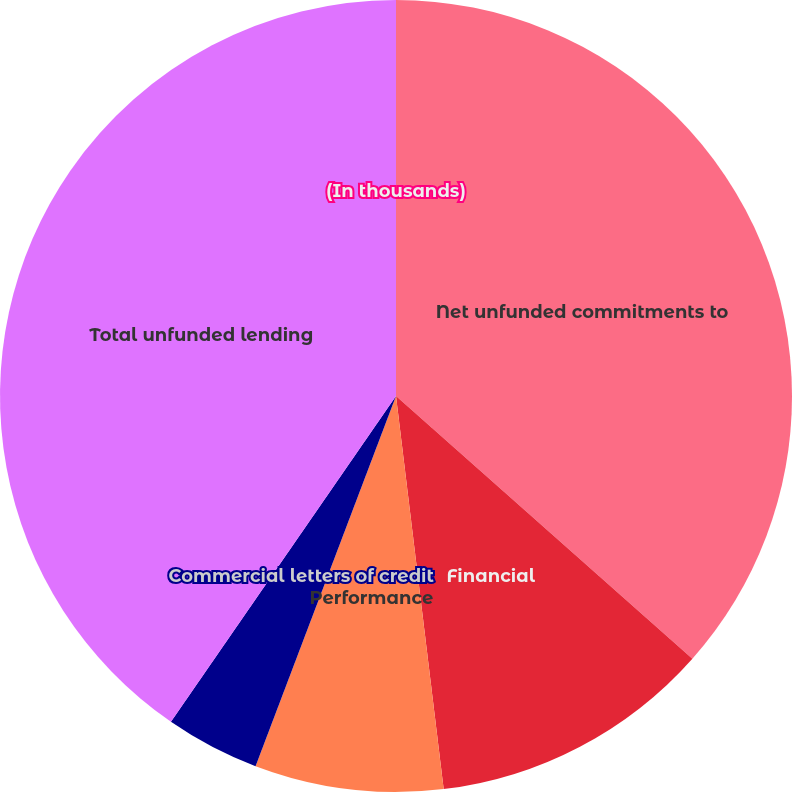Convert chart to OTSL. <chart><loc_0><loc_0><loc_500><loc_500><pie_chart><fcel>(In thousands)<fcel>Net unfunded commitments to<fcel>Financial<fcel>Performance<fcel>Commercial letters of credit<fcel>Total unfunded lending<nl><fcel>0.0%<fcel>36.54%<fcel>11.54%<fcel>7.69%<fcel>3.85%<fcel>40.38%<nl></chart> 